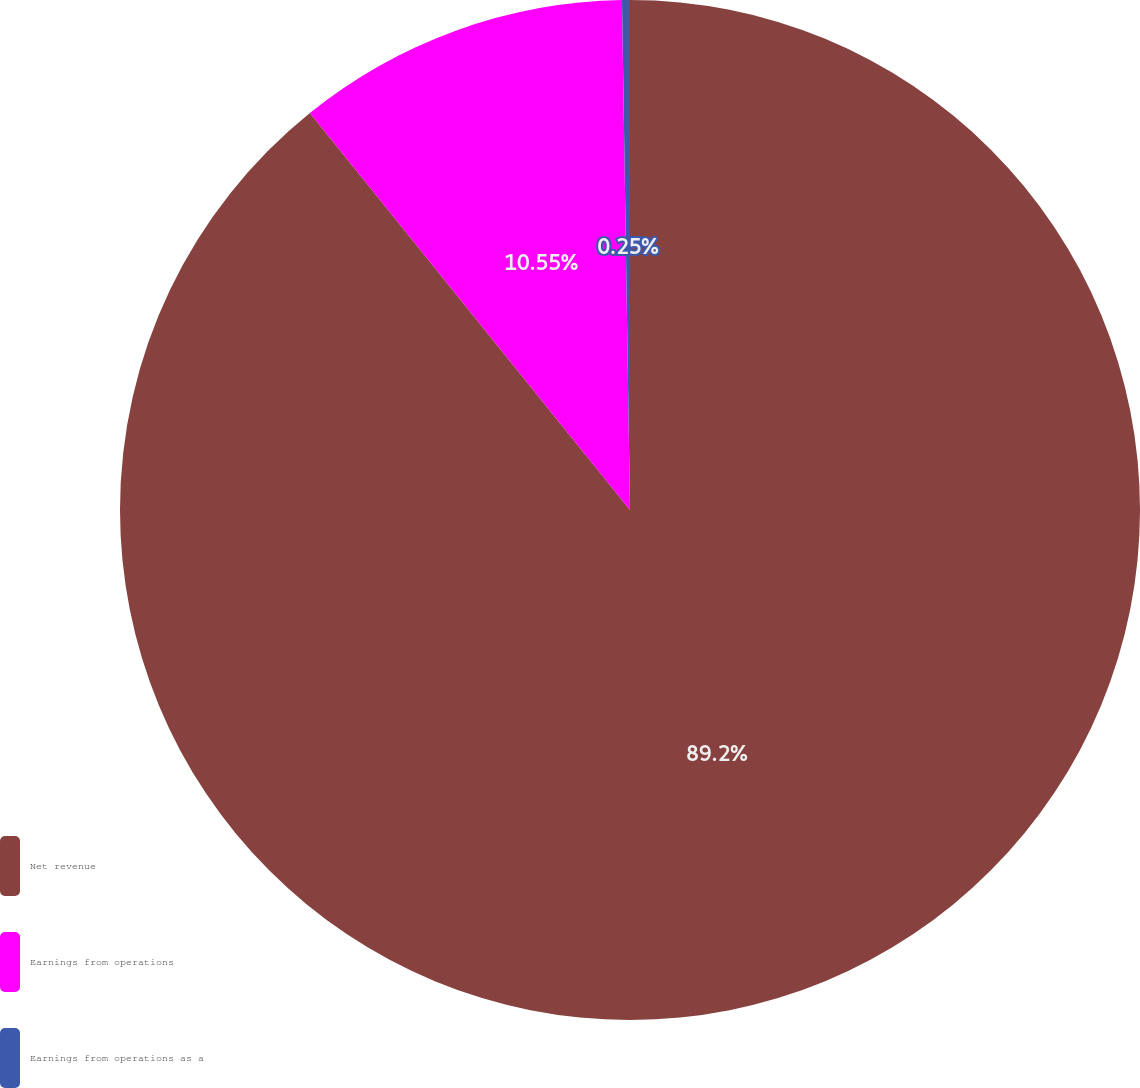Convert chart to OTSL. <chart><loc_0><loc_0><loc_500><loc_500><pie_chart><fcel>Net revenue<fcel>Earnings from operations<fcel>Earnings from operations as a<nl><fcel>89.2%<fcel>10.55%<fcel>0.25%<nl></chart> 